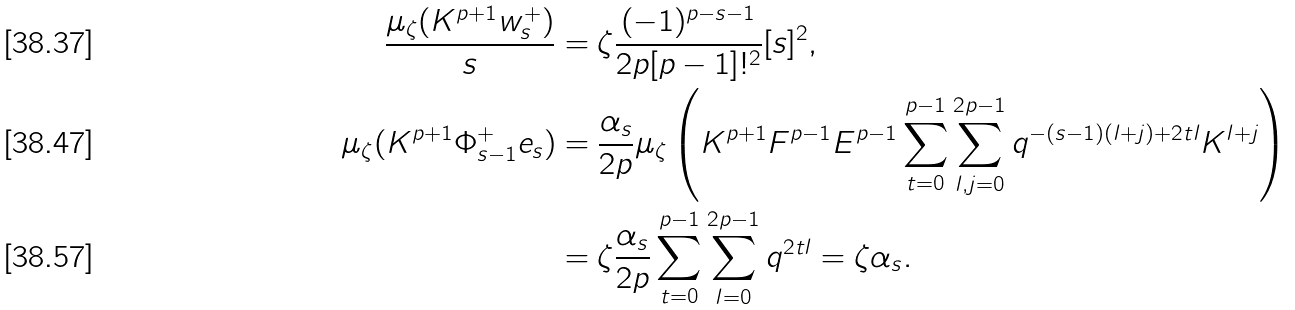Convert formula to latex. <formula><loc_0><loc_0><loc_500><loc_500>\frac { \mu _ { \zeta } ( K ^ { p + 1 } w ^ { + } _ { s } ) } { s } & = \zeta \frac { ( - 1 ) ^ { p - s - 1 } } { 2 p [ p - 1 ] ! ^ { 2 } } [ s ] ^ { 2 } , \\ \mu _ { \zeta } ( K ^ { p + 1 } \Phi ^ { + } _ { s - 1 } e _ { s } ) & = \frac { \alpha _ { s } } { 2 p } \mu _ { \zeta } \left ( K ^ { p + 1 } F ^ { p - 1 } E ^ { p - 1 } \sum _ { t = 0 } ^ { p - 1 } \sum _ { l , j = 0 } ^ { 2 p - 1 } q ^ { - ( s - 1 ) ( l + j ) + 2 t l } K ^ { l + j } \right ) \\ & = \zeta \frac { \alpha _ { s } } { 2 p } \sum _ { t = 0 } ^ { p - 1 } \sum _ { l = 0 } ^ { 2 p - 1 } q ^ { 2 t l } = \zeta \alpha _ { s } .</formula> 